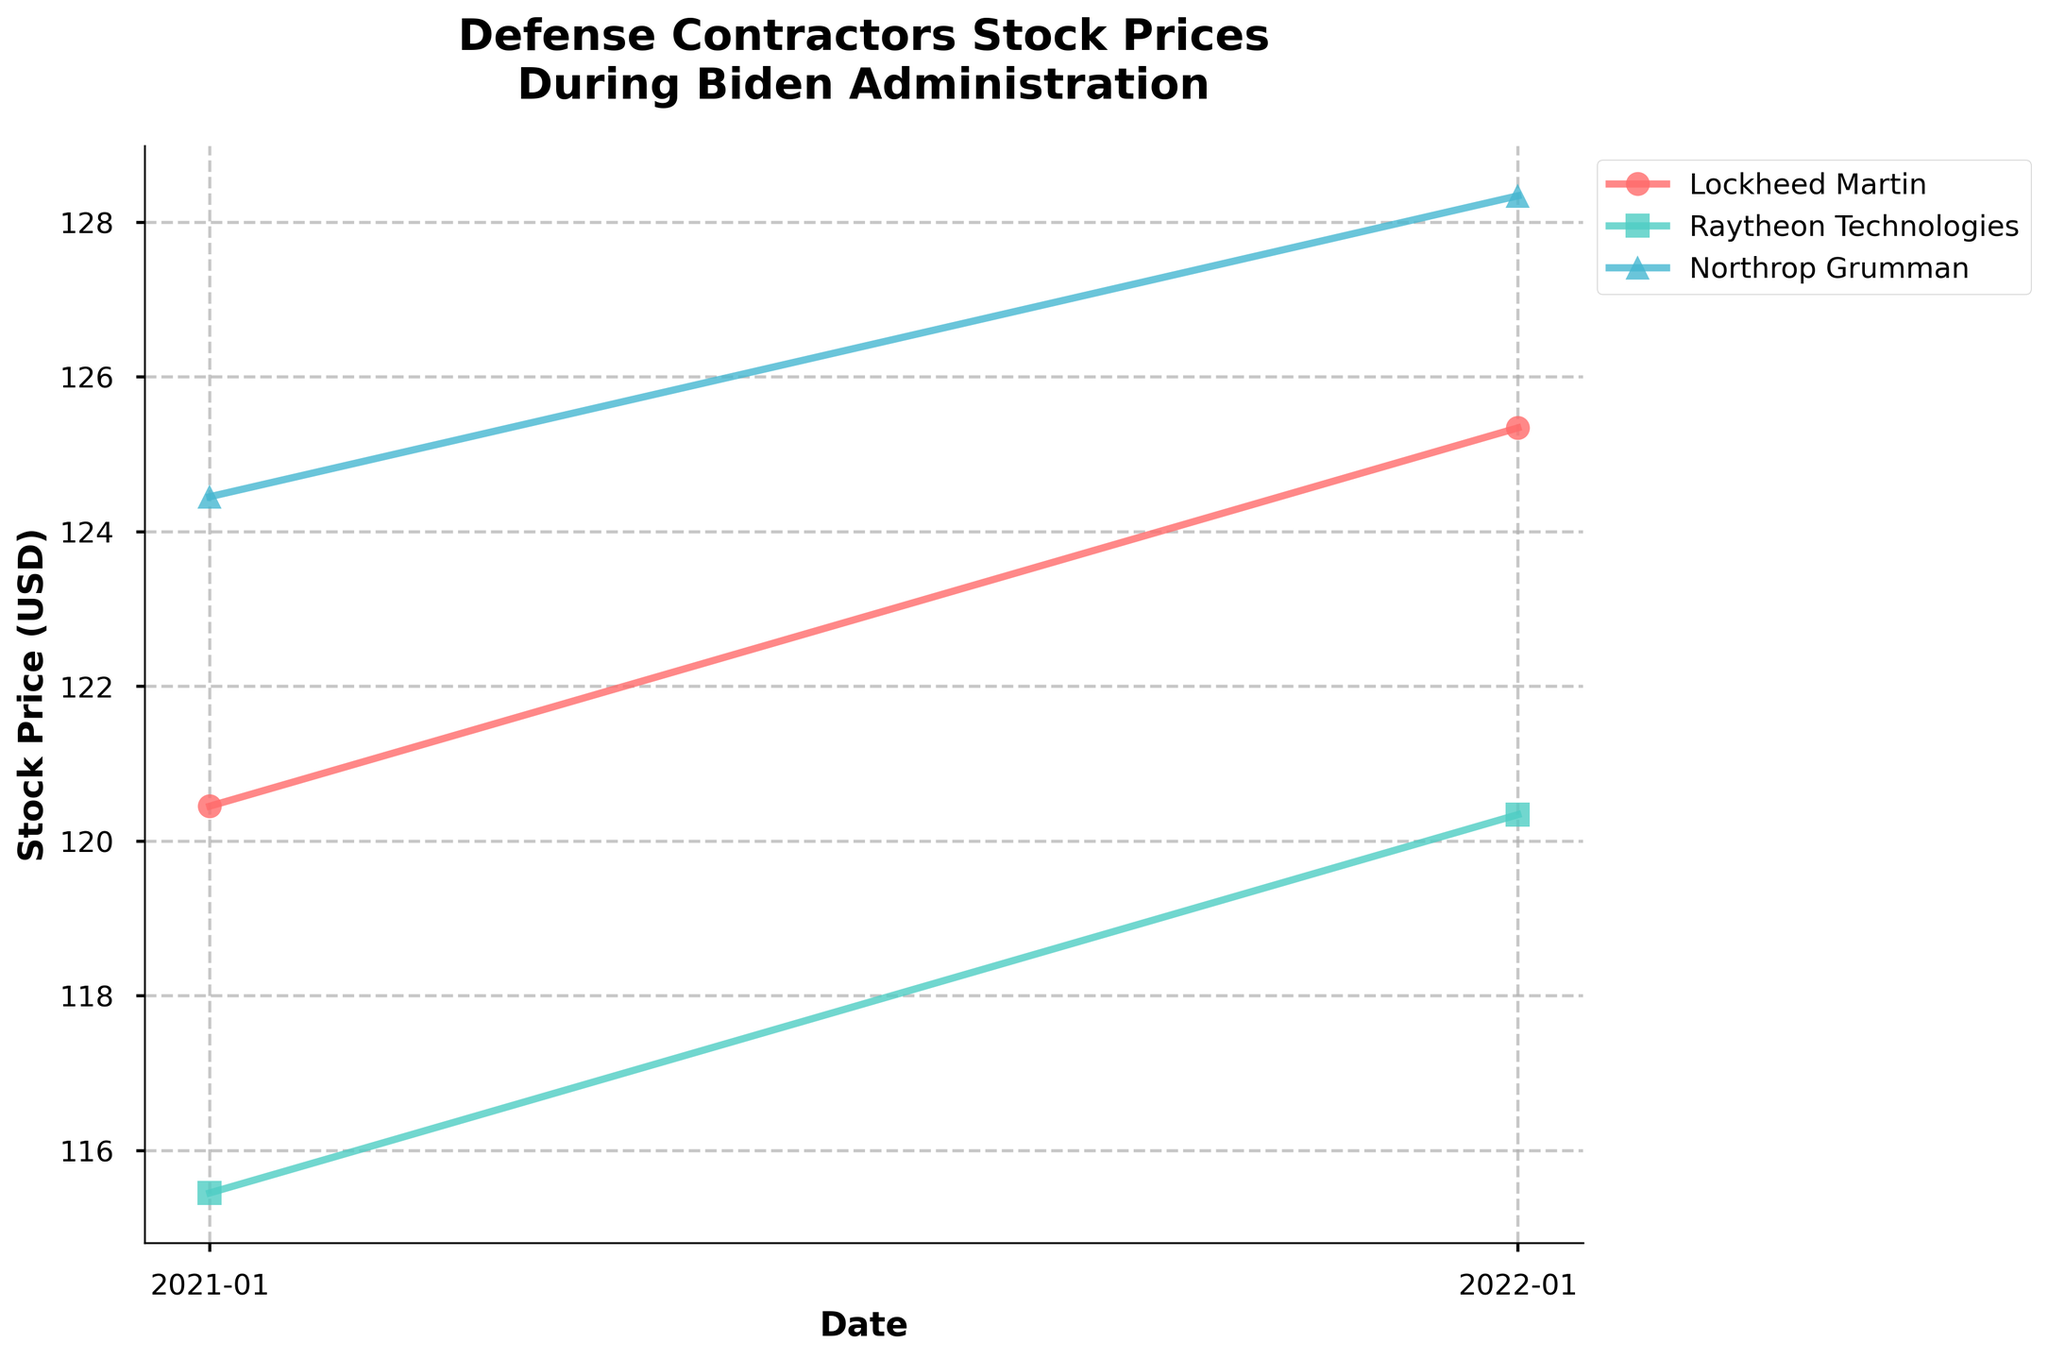What is the title of the plot? Look at the top of the plot where the title is normally placed. It states: 'Defense Contractors Stock Prices\nDuring Biden Administration'.
Answer: Defense Contractors Stock Prices During Biden Administration What are the names of the defense contractors represented in the plot? The plot legend, which is usually located to one side of the plot or just beneath the title, lists the names of the contractors. Here we see: Lockheed Martin, Raytheon Technologies, and Northrop Grumman.
Answer: Lockheed Martin, Raytheon Technologies, Northrop Grumman How does the stock price of Lockheed Martin in January 2022 compare to January 2021? Refer to the data points along the line corresponding to Lockheed Martin, identified by its color and marker. The price in January 2021 is 120.45 and in January 2022 is 125.34. Subtract the former from the latter to find the difference. 125.34 - 120.45 = 4.89.
Answer: 4.89 Which contractor had the highest stock price in January 2022? Check the data points for January 2022 for each contractor. The stock prices are 125.34 (Lockheed Martin), 120.34 (Raytheon Technologies), and 128.34 (Northrop Grumman). The highest value among these is 128.34.
Answer: Northrop Grumman Which contractor experienced the smallest change in stock price from January 2021 to January 2022? Calculate the difference in stock prices between January 2021 and January 2022 for each contractor. The changes are 125.34 - 120.45 = 4.89 (Lockheed Martin), 120.34 - 115.45 = 4.89 (Raytheon Technologies), 128.34 - 124.45 = 3.89 (Northrop Grumman). The smallest change is 3.89.
Answer: Northrop Grumman What is the average stock price of Raytheon Technologies during the Biden Administration mentioned in the plot? Average is calculated by summing the stock prices over the period and dividing by the number of data points. For Raytheon Technologies, it's (115.45 + 120.34) / 2.
Answer: 117.90 In the given plot, which administration's stock prices are depicted for the contractors? The title of the plot explicitly mentions 'During Biden Administration', indicating that stock prices for the contractors during the Biden administration are depicted.
Answer: Biden Administration How many data points are plotted for each contractor? Check the plot and count the markers for each contractor's line. Each contractor has two data points (January 2021 and January 2022).
Answer: 2 